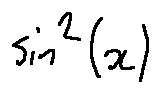Convert formula to latex. <formula><loc_0><loc_0><loc_500><loc_500>\sin ^ { 2 } ( x )</formula> 